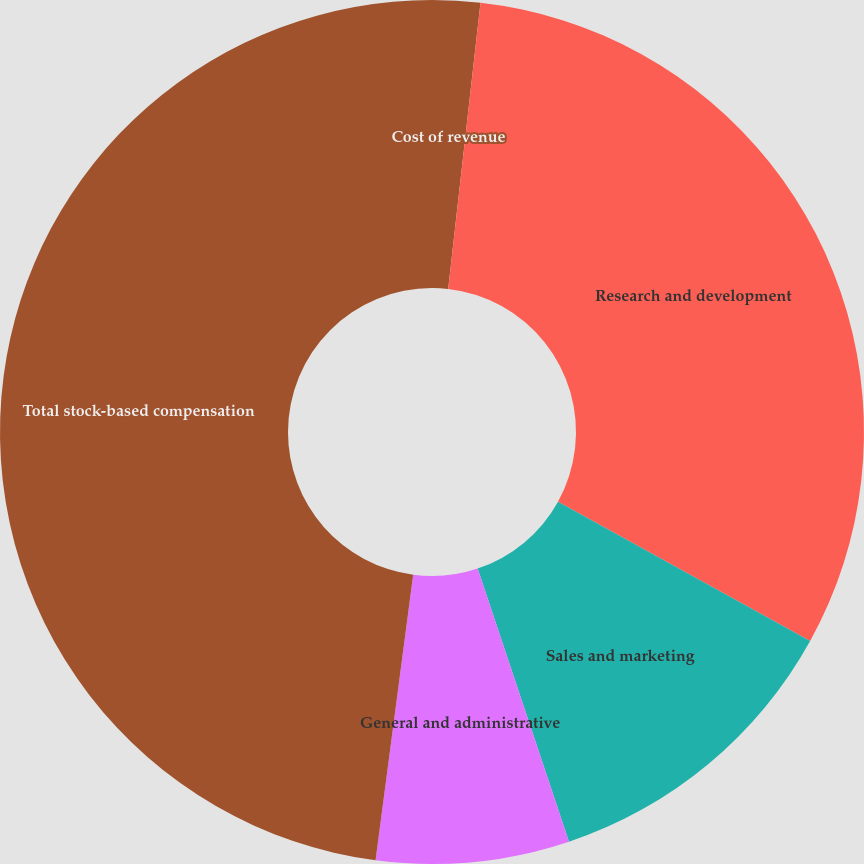Convert chart. <chart><loc_0><loc_0><loc_500><loc_500><pie_chart><fcel>Cost of revenue<fcel>Research and development<fcel>Sales and marketing<fcel>General and administrative<fcel>Total stock-based compensation<nl><fcel>1.79%<fcel>31.24%<fcel>11.83%<fcel>7.22%<fcel>47.91%<nl></chart> 